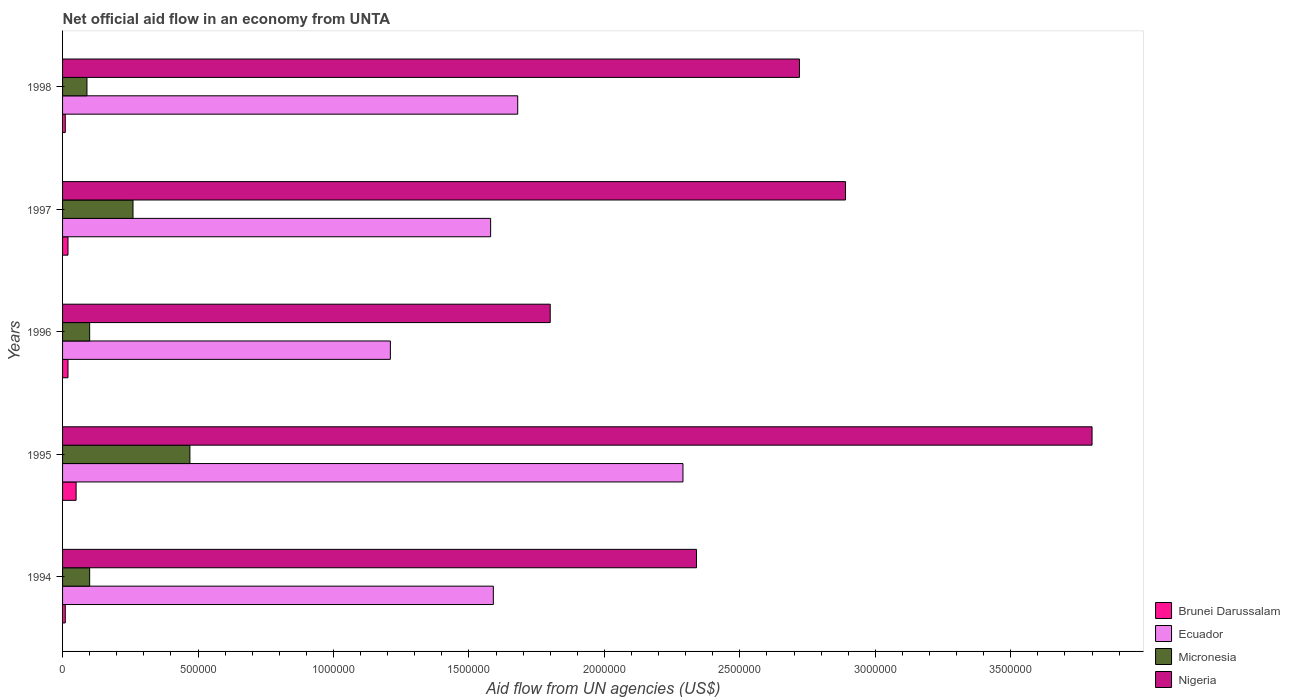How many different coloured bars are there?
Give a very brief answer. 4. How many groups of bars are there?
Your answer should be compact. 5. What is the label of the 2nd group of bars from the top?
Offer a terse response. 1997. What is the net official aid flow in Micronesia in 1994?
Provide a succinct answer. 1.00e+05. Across all years, what is the minimum net official aid flow in Nigeria?
Ensure brevity in your answer.  1.80e+06. What is the total net official aid flow in Micronesia in the graph?
Make the answer very short. 1.02e+06. What is the difference between the net official aid flow in Micronesia in 1994 and that in 1998?
Your response must be concise. 10000. What is the difference between the net official aid flow in Micronesia in 1994 and the net official aid flow in Ecuador in 1997?
Your response must be concise. -1.48e+06. What is the average net official aid flow in Brunei Darussalam per year?
Provide a short and direct response. 2.20e+04. In the year 1996, what is the difference between the net official aid flow in Brunei Darussalam and net official aid flow in Ecuador?
Offer a terse response. -1.19e+06. What is the ratio of the net official aid flow in Micronesia in 1994 to that in 1997?
Your response must be concise. 0.38. Is the net official aid flow in Ecuador in 1994 less than that in 1995?
Ensure brevity in your answer.  Yes. Is it the case that in every year, the sum of the net official aid flow in Micronesia and net official aid flow in Brunei Darussalam is greater than the sum of net official aid flow in Nigeria and net official aid flow in Ecuador?
Offer a very short reply. No. What does the 4th bar from the top in 1996 represents?
Provide a short and direct response. Brunei Darussalam. What does the 1st bar from the bottom in 1994 represents?
Make the answer very short. Brunei Darussalam. Is it the case that in every year, the sum of the net official aid flow in Brunei Darussalam and net official aid flow in Ecuador is greater than the net official aid flow in Micronesia?
Make the answer very short. Yes. How many bars are there?
Make the answer very short. 20. How many years are there in the graph?
Ensure brevity in your answer.  5. What is the difference between two consecutive major ticks on the X-axis?
Keep it short and to the point. 5.00e+05. Where does the legend appear in the graph?
Provide a short and direct response. Bottom right. How many legend labels are there?
Your answer should be compact. 4. How are the legend labels stacked?
Offer a very short reply. Vertical. What is the title of the graph?
Your response must be concise. Net official aid flow in an economy from UNTA. Does "Bhutan" appear as one of the legend labels in the graph?
Your response must be concise. No. What is the label or title of the X-axis?
Give a very brief answer. Aid flow from UN agencies (US$). What is the label or title of the Y-axis?
Provide a short and direct response. Years. What is the Aid flow from UN agencies (US$) in Ecuador in 1994?
Provide a short and direct response. 1.59e+06. What is the Aid flow from UN agencies (US$) in Nigeria in 1994?
Your answer should be very brief. 2.34e+06. What is the Aid flow from UN agencies (US$) of Ecuador in 1995?
Your answer should be compact. 2.29e+06. What is the Aid flow from UN agencies (US$) in Micronesia in 1995?
Give a very brief answer. 4.70e+05. What is the Aid flow from UN agencies (US$) in Nigeria in 1995?
Offer a very short reply. 3.80e+06. What is the Aid flow from UN agencies (US$) of Brunei Darussalam in 1996?
Your answer should be compact. 2.00e+04. What is the Aid flow from UN agencies (US$) of Ecuador in 1996?
Provide a succinct answer. 1.21e+06. What is the Aid flow from UN agencies (US$) in Nigeria in 1996?
Offer a terse response. 1.80e+06. What is the Aid flow from UN agencies (US$) of Ecuador in 1997?
Make the answer very short. 1.58e+06. What is the Aid flow from UN agencies (US$) in Nigeria in 1997?
Keep it short and to the point. 2.89e+06. What is the Aid flow from UN agencies (US$) in Brunei Darussalam in 1998?
Keep it short and to the point. 10000. What is the Aid flow from UN agencies (US$) of Ecuador in 1998?
Make the answer very short. 1.68e+06. What is the Aid flow from UN agencies (US$) of Micronesia in 1998?
Give a very brief answer. 9.00e+04. What is the Aid flow from UN agencies (US$) of Nigeria in 1998?
Your answer should be very brief. 2.72e+06. Across all years, what is the maximum Aid flow from UN agencies (US$) of Ecuador?
Provide a succinct answer. 2.29e+06. Across all years, what is the maximum Aid flow from UN agencies (US$) of Nigeria?
Provide a short and direct response. 3.80e+06. Across all years, what is the minimum Aid flow from UN agencies (US$) of Ecuador?
Your answer should be compact. 1.21e+06. Across all years, what is the minimum Aid flow from UN agencies (US$) in Nigeria?
Offer a very short reply. 1.80e+06. What is the total Aid flow from UN agencies (US$) of Ecuador in the graph?
Keep it short and to the point. 8.35e+06. What is the total Aid flow from UN agencies (US$) of Micronesia in the graph?
Your answer should be compact. 1.02e+06. What is the total Aid flow from UN agencies (US$) in Nigeria in the graph?
Provide a succinct answer. 1.36e+07. What is the difference between the Aid flow from UN agencies (US$) of Ecuador in 1994 and that in 1995?
Offer a very short reply. -7.00e+05. What is the difference between the Aid flow from UN agencies (US$) of Micronesia in 1994 and that in 1995?
Offer a terse response. -3.70e+05. What is the difference between the Aid flow from UN agencies (US$) in Nigeria in 1994 and that in 1995?
Give a very brief answer. -1.46e+06. What is the difference between the Aid flow from UN agencies (US$) in Brunei Darussalam in 1994 and that in 1996?
Offer a very short reply. -10000. What is the difference between the Aid flow from UN agencies (US$) of Ecuador in 1994 and that in 1996?
Your response must be concise. 3.80e+05. What is the difference between the Aid flow from UN agencies (US$) in Nigeria in 1994 and that in 1996?
Your answer should be very brief. 5.40e+05. What is the difference between the Aid flow from UN agencies (US$) of Ecuador in 1994 and that in 1997?
Your answer should be compact. 10000. What is the difference between the Aid flow from UN agencies (US$) of Nigeria in 1994 and that in 1997?
Offer a very short reply. -5.50e+05. What is the difference between the Aid flow from UN agencies (US$) in Ecuador in 1994 and that in 1998?
Offer a very short reply. -9.00e+04. What is the difference between the Aid flow from UN agencies (US$) of Micronesia in 1994 and that in 1998?
Offer a terse response. 10000. What is the difference between the Aid flow from UN agencies (US$) in Nigeria in 1994 and that in 1998?
Ensure brevity in your answer.  -3.80e+05. What is the difference between the Aid flow from UN agencies (US$) in Brunei Darussalam in 1995 and that in 1996?
Keep it short and to the point. 3.00e+04. What is the difference between the Aid flow from UN agencies (US$) in Ecuador in 1995 and that in 1996?
Provide a short and direct response. 1.08e+06. What is the difference between the Aid flow from UN agencies (US$) of Ecuador in 1995 and that in 1997?
Your answer should be very brief. 7.10e+05. What is the difference between the Aid flow from UN agencies (US$) of Nigeria in 1995 and that in 1997?
Offer a very short reply. 9.10e+05. What is the difference between the Aid flow from UN agencies (US$) of Micronesia in 1995 and that in 1998?
Provide a short and direct response. 3.80e+05. What is the difference between the Aid flow from UN agencies (US$) in Nigeria in 1995 and that in 1998?
Your response must be concise. 1.08e+06. What is the difference between the Aid flow from UN agencies (US$) of Brunei Darussalam in 1996 and that in 1997?
Ensure brevity in your answer.  0. What is the difference between the Aid flow from UN agencies (US$) of Ecuador in 1996 and that in 1997?
Offer a very short reply. -3.70e+05. What is the difference between the Aid flow from UN agencies (US$) of Nigeria in 1996 and that in 1997?
Provide a short and direct response. -1.09e+06. What is the difference between the Aid flow from UN agencies (US$) in Brunei Darussalam in 1996 and that in 1998?
Offer a very short reply. 10000. What is the difference between the Aid flow from UN agencies (US$) of Ecuador in 1996 and that in 1998?
Keep it short and to the point. -4.70e+05. What is the difference between the Aid flow from UN agencies (US$) in Micronesia in 1996 and that in 1998?
Provide a short and direct response. 10000. What is the difference between the Aid flow from UN agencies (US$) in Nigeria in 1996 and that in 1998?
Make the answer very short. -9.20e+05. What is the difference between the Aid flow from UN agencies (US$) in Ecuador in 1997 and that in 1998?
Ensure brevity in your answer.  -1.00e+05. What is the difference between the Aid flow from UN agencies (US$) of Micronesia in 1997 and that in 1998?
Provide a short and direct response. 1.70e+05. What is the difference between the Aid flow from UN agencies (US$) in Nigeria in 1997 and that in 1998?
Your answer should be compact. 1.70e+05. What is the difference between the Aid flow from UN agencies (US$) of Brunei Darussalam in 1994 and the Aid flow from UN agencies (US$) of Ecuador in 1995?
Your answer should be compact. -2.28e+06. What is the difference between the Aid flow from UN agencies (US$) in Brunei Darussalam in 1994 and the Aid flow from UN agencies (US$) in Micronesia in 1995?
Give a very brief answer. -4.60e+05. What is the difference between the Aid flow from UN agencies (US$) in Brunei Darussalam in 1994 and the Aid flow from UN agencies (US$) in Nigeria in 1995?
Provide a succinct answer. -3.79e+06. What is the difference between the Aid flow from UN agencies (US$) in Ecuador in 1994 and the Aid flow from UN agencies (US$) in Micronesia in 1995?
Ensure brevity in your answer.  1.12e+06. What is the difference between the Aid flow from UN agencies (US$) of Ecuador in 1994 and the Aid flow from UN agencies (US$) of Nigeria in 1995?
Your response must be concise. -2.21e+06. What is the difference between the Aid flow from UN agencies (US$) in Micronesia in 1994 and the Aid flow from UN agencies (US$) in Nigeria in 1995?
Give a very brief answer. -3.70e+06. What is the difference between the Aid flow from UN agencies (US$) in Brunei Darussalam in 1994 and the Aid flow from UN agencies (US$) in Ecuador in 1996?
Ensure brevity in your answer.  -1.20e+06. What is the difference between the Aid flow from UN agencies (US$) of Brunei Darussalam in 1994 and the Aid flow from UN agencies (US$) of Nigeria in 1996?
Offer a terse response. -1.79e+06. What is the difference between the Aid flow from UN agencies (US$) in Ecuador in 1994 and the Aid flow from UN agencies (US$) in Micronesia in 1996?
Your answer should be compact. 1.49e+06. What is the difference between the Aid flow from UN agencies (US$) in Ecuador in 1994 and the Aid flow from UN agencies (US$) in Nigeria in 1996?
Offer a terse response. -2.10e+05. What is the difference between the Aid flow from UN agencies (US$) in Micronesia in 1994 and the Aid flow from UN agencies (US$) in Nigeria in 1996?
Your answer should be compact. -1.70e+06. What is the difference between the Aid flow from UN agencies (US$) of Brunei Darussalam in 1994 and the Aid flow from UN agencies (US$) of Ecuador in 1997?
Your answer should be compact. -1.57e+06. What is the difference between the Aid flow from UN agencies (US$) of Brunei Darussalam in 1994 and the Aid flow from UN agencies (US$) of Micronesia in 1997?
Offer a terse response. -2.50e+05. What is the difference between the Aid flow from UN agencies (US$) of Brunei Darussalam in 1994 and the Aid flow from UN agencies (US$) of Nigeria in 1997?
Offer a very short reply. -2.88e+06. What is the difference between the Aid flow from UN agencies (US$) of Ecuador in 1994 and the Aid flow from UN agencies (US$) of Micronesia in 1997?
Offer a terse response. 1.33e+06. What is the difference between the Aid flow from UN agencies (US$) in Ecuador in 1994 and the Aid flow from UN agencies (US$) in Nigeria in 1997?
Offer a terse response. -1.30e+06. What is the difference between the Aid flow from UN agencies (US$) of Micronesia in 1994 and the Aid flow from UN agencies (US$) of Nigeria in 1997?
Offer a very short reply. -2.79e+06. What is the difference between the Aid flow from UN agencies (US$) in Brunei Darussalam in 1994 and the Aid flow from UN agencies (US$) in Ecuador in 1998?
Keep it short and to the point. -1.67e+06. What is the difference between the Aid flow from UN agencies (US$) in Brunei Darussalam in 1994 and the Aid flow from UN agencies (US$) in Micronesia in 1998?
Keep it short and to the point. -8.00e+04. What is the difference between the Aid flow from UN agencies (US$) of Brunei Darussalam in 1994 and the Aid flow from UN agencies (US$) of Nigeria in 1998?
Your answer should be compact. -2.71e+06. What is the difference between the Aid flow from UN agencies (US$) of Ecuador in 1994 and the Aid flow from UN agencies (US$) of Micronesia in 1998?
Give a very brief answer. 1.50e+06. What is the difference between the Aid flow from UN agencies (US$) of Ecuador in 1994 and the Aid flow from UN agencies (US$) of Nigeria in 1998?
Your answer should be compact. -1.13e+06. What is the difference between the Aid flow from UN agencies (US$) of Micronesia in 1994 and the Aid flow from UN agencies (US$) of Nigeria in 1998?
Your response must be concise. -2.62e+06. What is the difference between the Aid flow from UN agencies (US$) of Brunei Darussalam in 1995 and the Aid flow from UN agencies (US$) of Ecuador in 1996?
Make the answer very short. -1.16e+06. What is the difference between the Aid flow from UN agencies (US$) of Brunei Darussalam in 1995 and the Aid flow from UN agencies (US$) of Nigeria in 1996?
Your answer should be very brief. -1.75e+06. What is the difference between the Aid flow from UN agencies (US$) in Ecuador in 1995 and the Aid flow from UN agencies (US$) in Micronesia in 1996?
Make the answer very short. 2.19e+06. What is the difference between the Aid flow from UN agencies (US$) of Micronesia in 1995 and the Aid flow from UN agencies (US$) of Nigeria in 1996?
Ensure brevity in your answer.  -1.33e+06. What is the difference between the Aid flow from UN agencies (US$) of Brunei Darussalam in 1995 and the Aid flow from UN agencies (US$) of Ecuador in 1997?
Your response must be concise. -1.53e+06. What is the difference between the Aid flow from UN agencies (US$) of Brunei Darussalam in 1995 and the Aid flow from UN agencies (US$) of Nigeria in 1997?
Provide a short and direct response. -2.84e+06. What is the difference between the Aid flow from UN agencies (US$) of Ecuador in 1995 and the Aid flow from UN agencies (US$) of Micronesia in 1997?
Offer a very short reply. 2.03e+06. What is the difference between the Aid flow from UN agencies (US$) of Ecuador in 1995 and the Aid flow from UN agencies (US$) of Nigeria in 1997?
Your answer should be very brief. -6.00e+05. What is the difference between the Aid flow from UN agencies (US$) of Micronesia in 1995 and the Aid flow from UN agencies (US$) of Nigeria in 1997?
Keep it short and to the point. -2.42e+06. What is the difference between the Aid flow from UN agencies (US$) in Brunei Darussalam in 1995 and the Aid flow from UN agencies (US$) in Ecuador in 1998?
Make the answer very short. -1.63e+06. What is the difference between the Aid flow from UN agencies (US$) of Brunei Darussalam in 1995 and the Aid flow from UN agencies (US$) of Micronesia in 1998?
Your response must be concise. -4.00e+04. What is the difference between the Aid flow from UN agencies (US$) in Brunei Darussalam in 1995 and the Aid flow from UN agencies (US$) in Nigeria in 1998?
Give a very brief answer. -2.67e+06. What is the difference between the Aid flow from UN agencies (US$) in Ecuador in 1995 and the Aid flow from UN agencies (US$) in Micronesia in 1998?
Give a very brief answer. 2.20e+06. What is the difference between the Aid flow from UN agencies (US$) in Ecuador in 1995 and the Aid flow from UN agencies (US$) in Nigeria in 1998?
Provide a succinct answer. -4.30e+05. What is the difference between the Aid flow from UN agencies (US$) of Micronesia in 1995 and the Aid flow from UN agencies (US$) of Nigeria in 1998?
Your answer should be compact. -2.25e+06. What is the difference between the Aid flow from UN agencies (US$) in Brunei Darussalam in 1996 and the Aid flow from UN agencies (US$) in Ecuador in 1997?
Make the answer very short. -1.56e+06. What is the difference between the Aid flow from UN agencies (US$) in Brunei Darussalam in 1996 and the Aid flow from UN agencies (US$) in Nigeria in 1997?
Your response must be concise. -2.87e+06. What is the difference between the Aid flow from UN agencies (US$) of Ecuador in 1996 and the Aid flow from UN agencies (US$) of Micronesia in 1997?
Offer a very short reply. 9.50e+05. What is the difference between the Aid flow from UN agencies (US$) in Ecuador in 1996 and the Aid flow from UN agencies (US$) in Nigeria in 1997?
Offer a terse response. -1.68e+06. What is the difference between the Aid flow from UN agencies (US$) in Micronesia in 1996 and the Aid flow from UN agencies (US$) in Nigeria in 1997?
Ensure brevity in your answer.  -2.79e+06. What is the difference between the Aid flow from UN agencies (US$) in Brunei Darussalam in 1996 and the Aid flow from UN agencies (US$) in Ecuador in 1998?
Your answer should be compact. -1.66e+06. What is the difference between the Aid flow from UN agencies (US$) in Brunei Darussalam in 1996 and the Aid flow from UN agencies (US$) in Nigeria in 1998?
Your answer should be compact. -2.70e+06. What is the difference between the Aid flow from UN agencies (US$) of Ecuador in 1996 and the Aid flow from UN agencies (US$) of Micronesia in 1998?
Your answer should be very brief. 1.12e+06. What is the difference between the Aid flow from UN agencies (US$) of Ecuador in 1996 and the Aid flow from UN agencies (US$) of Nigeria in 1998?
Your answer should be compact. -1.51e+06. What is the difference between the Aid flow from UN agencies (US$) of Micronesia in 1996 and the Aid flow from UN agencies (US$) of Nigeria in 1998?
Your response must be concise. -2.62e+06. What is the difference between the Aid flow from UN agencies (US$) of Brunei Darussalam in 1997 and the Aid flow from UN agencies (US$) of Ecuador in 1998?
Keep it short and to the point. -1.66e+06. What is the difference between the Aid flow from UN agencies (US$) of Brunei Darussalam in 1997 and the Aid flow from UN agencies (US$) of Nigeria in 1998?
Your answer should be compact. -2.70e+06. What is the difference between the Aid flow from UN agencies (US$) of Ecuador in 1997 and the Aid flow from UN agencies (US$) of Micronesia in 1998?
Give a very brief answer. 1.49e+06. What is the difference between the Aid flow from UN agencies (US$) in Ecuador in 1997 and the Aid flow from UN agencies (US$) in Nigeria in 1998?
Provide a succinct answer. -1.14e+06. What is the difference between the Aid flow from UN agencies (US$) in Micronesia in 1997 and the Aid flow from UN agencies (US$) in Nigeria in 1998?
Your response must be concise. -2.46e+06. What is the average Aid flow from UN agencies (US$) in Brunei Darussalam per year?
Make the answer very short. 2.20e+04. What is the average Aid flow from UN agencies (US$) of Ecuador per year?
Offer a very short reply. 1.67e+06. What is the average Aid flow from UN agencies (US$) of Micronesia per year?
Ensure brevity in your answer.  2.04e+05. What is the average Aid flow from UN agencies (US$) in Nigeria per year?
Keep it short and to the point. 2.71e+06. In the year 1994, what is the difference between the Aid flow from UN agencies (US$) in Brunei Darussalam and Aid flow from UN agencies (US$) in Ecuador?
Provide a succinct answer. -1.58e+06. In the year 1994, what is the difference between the Aid flow from UN agencies (US$) of Brunei Darussalam and Aid flow from UN agencies (US$) of Micronesia?
Provide a succinct answer. -9.00e+04. In the year 1994, what is the difference between the Aid flow from UN agencies (US$) of Brunei Darussalam and Aid flow from UN agencies (US$) of Nigeria?
Ensure brevity in your answer.  -2.33e+06. In the year 1994, what is the difference between the Aid flow from UN agencies (US$) in Ecuador and Aid flow from UN agencies (US$) in Micronesia?
Provide a short and direct response. 1.49e+06. In the year 1994, what is the difference between the Aid flow from UN agencies (US$) in Ecuador and Aid flow from UN agencies (US$) in Nigeria?
Your answer should be compact. -7.50e+05. In the year 1994, what is the difference between the Aid flow from UN agencies (US$) in Micronesia and Aid flow from UN agencies (US$) in Nigeria?
Keep it short and to the point. -2.24e+06. In the year 1995, what is the difference between the Aid flow from UN agencies (US$) in Brunei Darussalam and Aid flow from UN agencies (US$) in Ecuador?
Your answer should be compact. -2.24e+06. In the year 1995, what is the difference between the Aid flow from UN agencies (US$) in Brunei Darussalam and Aid flow from UN agencies (US$) in Micronesia?
Ensure brevity in your answer.  -4.20e+05. In the year 1995, what is the difference between the Aid flow from UN agencies (US$) of Brunei Darussalam and Aid flow from UN agencies (US$) of Nigeria?
Keep it short and to the point. -3.75e+06. In the year 1995, what is the difference between the Aid flow from UN agencies (US$) of Ecuador and Aid flow from UN agencies (US$) of Micronesia?
Keep it short and to the point. 1.82e+06. In the year 1995, what is the difference between the Aid flow from UN agencies (US$) in Ecuador and Aid flow from UN agencies (US$) in Nigeria?
Offer a very short reply. -1.51e+06. In the year 1995, what is the difference between the Aid flow from UN agencies (US$) in Micronesia and Aid flow from UN agencies (US$) in Nigeria?
Offer a very short reply. -3.33e+06. In the year 1996, what is the difference between the Aid flow from UN agencies (US$) of Brunei Darussalam and Aid flow from UN agencies (US$) of Ecuador?
Give a very brief answer. -1.19e+06. In the year 1996, what is the difference between the Aid flow from UN agencies (US$) of Brunei Darussalam and Aid flow from UN agencies (US$) of Micronesia?
Your response must be concise. -8.00e+04. In the year 1996, what is the difference between the Aid flow from UN agencies (US$) in Brunei Darussalam and Aid flow from UN agencies (US$) in Nigeria?
Give a very brief answer. -1.78e+06. In the year 1996, what is the difference between the Aid flow from UN agencies (US$) in Ecuador and Aid flow from UN agencies (US$) in Micronesia?
Your answer should be very brief. 1.11e+06. In the year 1996, what is the difference between the Aid flow from UN agencies (US$) of Ecuador and Aid flow from UN agencies (US$) of Nigeria?
Offer a very short reply. -5.90e+05. In the year 1996, what is the difference between the Aid flow from UN agencies (US$) in Micronesia and Aid flow from UN agencies (US$) in Nigeria?
Provide a short and direct response. -1.70e+06. In the year 1997, what is the difference between the Aid flow from UN agencies (US$) in Brunei Darussalam and Aid flow from UN agencies (US$) in Ecuador?
Your answer should be very brief. -1.56e+06. In the year 1997, what is the difference between the Aid flow from UN agencies (US$) in Brunei Darussalam and Aid flow from UN agencies (US$) in Micronesia?
Provide a short and direct response. -2.40e+05. In the year 1997, what is the difference between the Aid flow from UN agencies (US$) of Brunei Darussalam and Aid flow from UN agencies (US$) of Nigeria?
Offer a terse response. -2.87e+06. In the year 1997, what is the difference between the Aid flow from UN agencies (US$) of Ecuador and Aid flow from UN agencies (US$) of Micronesia?
Ensure brevity in your answer.  1.32e+06. In the year 1997, what is the difference between the Aid flow from UN agencies (US$) in Ecuador and Aid flow from UN agencies (US$) in Nigeria?
Your answer should be very brief. -1.31e+06. In the year 1997, what is the difference between the Aid flow from UN agencies (US$) of Micronesia and Aid flow from UN agencies (US$) of Nigeria?
Give a very brief answer. -2.63e+06. In the year 1998, what is the difference between the Aid flow from UN agencies (US$) in Brunei Darussalam and Aid flow from UN agencies (US$) in Ecuador?
Offer a terse response. -1.67e+06. In the year 1998, what is the difference between the Aid flow from UN agencies (US$) of Brunei Darussalam and Aid flow from UN agencies (US$) of Micronesia?
Keep it short and to the point. -8.00e+04. In the year 1998, what is the difference between the Aid flow from UN agencies (US$) in Brunei Darussalam and Aid flow from UN agencies (US$) in Nigeria?
Keep it short and to the point. -2.71e+06. In the year 1998, what is the difference between the Aid flow from UN agencies (US$) of Ecuador and Aid flow from UN agencies (US$) of Micronesia?
Ensure brevity in your answer.  1.59e+06. In the year 1998, what is the difference between the Aid flow from UN agencies (US$) of Ecuador and Aid flow from UN agencies (US$) of Nigeria?
Offer a terse response. -1.04e+06. In the year 1998, what is the difference between the Aid flow from UN agencies (US$) in Micronesia and Aid flow from UN agencies (US$) in Nigeria?
Your answer should be very brief. -2.63e+06. What is the ratio of the Aid flow from UN agencies (US$) in Ecuador in 1994 to that in 1995?
Keep it short and to the point. 0.69. What is the ratio of the Aid flow from UN agencies (US$) in Micronesia in 1994 to that in 1995?
Your response must be concise. 0.21. What is the ratio of the Aid flow from UN agencies (US$) in Nigeria in 1994 to that in 1995?
Offer a terse response. 0.62. What is the ratio of the Aid flow from UN agencies (US$) of Ecuador in 1994 to that in 1996?
Ensure brevity in your answer.  1.31. What is the ratio of the Aid flow from UN agencies (US$) of Micronesia in 1994 to that in 1996?
Give a very brief answer. 1. What is the ratio of the Aid flow from UN agencies (US$) of Nigeria in 1994 to that in 1996?
Your response must be concise. 1.3. What is the ratio of the Aid flow from UN agencies (US$) in Brunei Darussalam in 1994 to that in 1997?
Your answer should be compact. 0.5. What is the ratio of the Aid flow from UN agencies (US$) in Ecuador in 1994 to that in 1997?
Your response must be concise. 1.01. What is the ratio of the Aid flow from UN agencies (US$) of Micronesia in 1994 to that in 1997?
Offer a very short reply. 0.38. What is the ratio of the Aid flow from UN agencies (US$) in Nigeria in 1994 to that in 1997?
Give a very brief answer. 0.81. What is the ratio of the Aid flow from UN agencies (US$) in Brunei Darussalam in 1994 to that in 1998?
Provide a succinct answer. 1. What is the ratio of the Aid flow from UN agencies (US$) of Ecuador in 1994 to that in 1998?
Give a very brief answer. 0.95. What is the ratio of the Aid flow from UN agencies (US$) of Micronesia in 1994 to that in 1998?
Your answer should be very brief. 1.11. What is the ratio of the Aid flow from UN agencies (US$) of Nigeria in 1994 to that in 1998?
Your answer should be compact. 0.86. What is the ratio of the Aid flow from UN agencies (US$) of Brunei Darussalam in 1995 to that in 1996?
Provide a short and direct response. 2.5. What is the ratio of the Aid flow from UN agencies (US$) in Ecuador in 1995 to that in 1996?
Your response must be concise. 1.89. What is the ratio of the Aid flow from UN agencies (US$) in Micronesia in 1995 to that in 1996?
Ensure brevity in your answer.  4.7. What is the ratio of the Aid flow from UN agencies (US$) of Nigeria in 1995 to that in 1996?
Your answer should be compact. 2.11. What is the ratio of the Aid flow from UN agencies (US$) in Ecuador in 1995 to that in 1997?
Provide a succinct answer. 1.45. What is the ratio of the Aid flow from UN agencies (US$) in Micronesia in 1995 to that in 1997?
Ensure brevity in your answer.  1.81. What is the ratio of the Aid flow from UN agencies (US$) of Nigeria in 1995 to that in 1997?
Keep it short and to the point. 1.31. What is the ratio of the Aid flow from UN agencies (US$) of Brunei Darussalam in 1995 to that in 1998?
Provide a succinct answer. 5. What is the ratio of the Aid flow from UN agencies (US$) in Ecuador in 1995 to that in 1998?
Provide a short and direct response. 1.36. What is the ratio of the Aid flow from UN agencies (US$) of Micronesia in 1995 to that in 1998?
Provide a short and direct response. 5.22. What is the ratio of the Aid flow from UN agencies (US$) of Nigeria in 1995 to that in 1998?
Make the answer very short. 1.4. What is the ratio of the Aid flow from UN agencies (US$) of Brunei Darussalam in 1996 to that in 1997?
Your answer should be very brief. 1. What is the ratio of the Aid flow from UN agencies (US$) in Ecuador in 1996 to that in 1997?
Keep it short and to the point. 0.77. What is the ratio of the Aid flow from UN agencies (US$) of Micronesia in 1996 to that in 1997?
Your response must be concise. 0.38. What is the ratio of the Aid flow from UN agencies (US$) in Nigeria in 1996 to that in 1997?
Ensure brevity in your answer.  0.62. What is the ratio of the Aid flow from UN agencies (US$) of Ecuador in 1996 to that in 1998?
Keep it short and to the point. 0.72. What is the ratio of the Aid flow from UN agencies (US$) in Nigeria in 1996 to that in 1998?
Ensure brevity in your answer.  0.66. What is the ratio of the Aid flow from UN agencies (US$) of Ecuador in 1997 to that in 1998?
Offer a terse response. 0.94. What is the ratio of the Aid flow from UN agencies (US$) of Micronesia in 1997 to that in 1998?
Keep it short and to the point. 2.89. What is the ratio of the Aid flow from UN agencies (US$) of Nigeria in 1997 to that in 1998?
Offer a very short reply. 1.06. What is the difference between the highest and the second highest Aid flow from UN agencies (US$) in Brunei Darussalam?
Offer a terse response. 3.00e+04. What is the difference between the highest and the second highest Aid flow from UN agencies (US$) in Ecuador?
Make the answer very short. 6.10e+05. What is the difference between the highest and the second highest Aid flow from UN agencies (US$) in Micronesia?
Ensure brevity in your answer.  2.10e+05. What is the difference between the highest and the second highest Aid flow from UN agencies (US$) in Nigeria?
Offer a terse response. 9.10e+05. What is the difference between the highest and the lowest Aid flow from UN agencies (US$) of Brunei Darussalam?
Offer a very short reply. 4.00e+04. What is the difference between the highest and the lowest Aid flow from UN agencies (US$) in Ecuador?
Make the answer very short. 1.08e+06. 